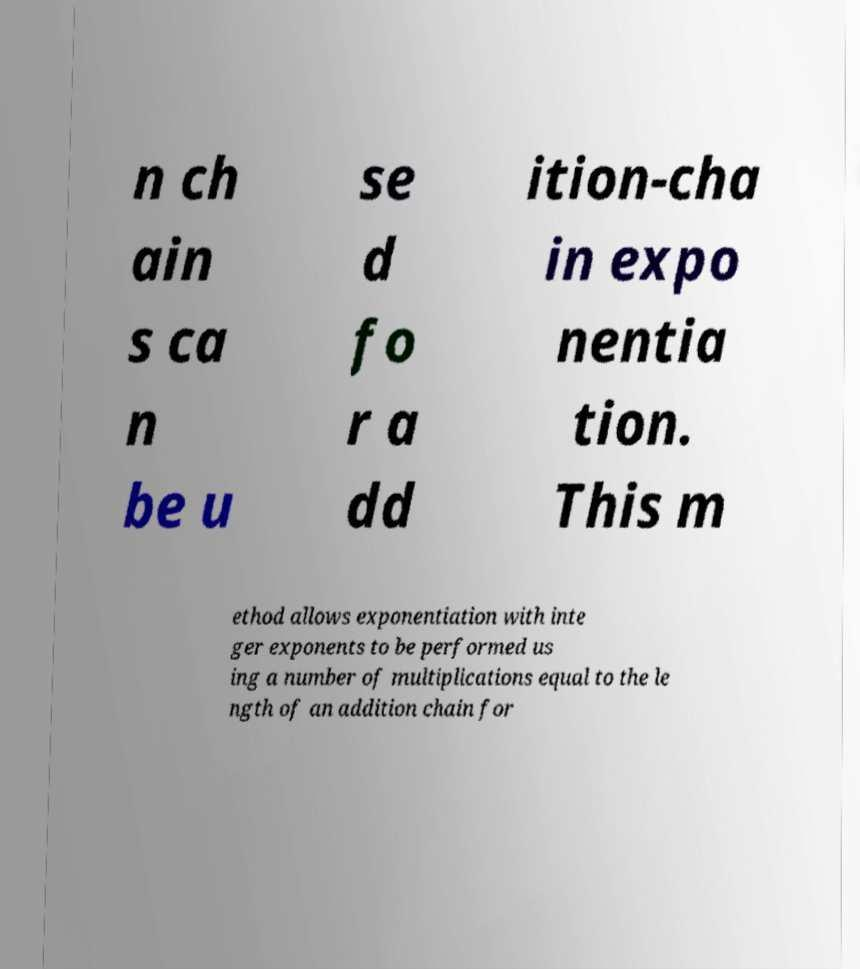I need the written content from this picture converted into text. Can you do that? n ch ain s ca n be u se d fo r a dd ition-cha in expo nentia tion. This m ethod allows exponentiation with inte ger exponents to be performed us ing a number of multiplications equal to the le ngth of an addition chain for 